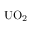<formula> <loc_0><loc_0><loc_500><loc_500>{ U O } _ { 2 }</formula> 